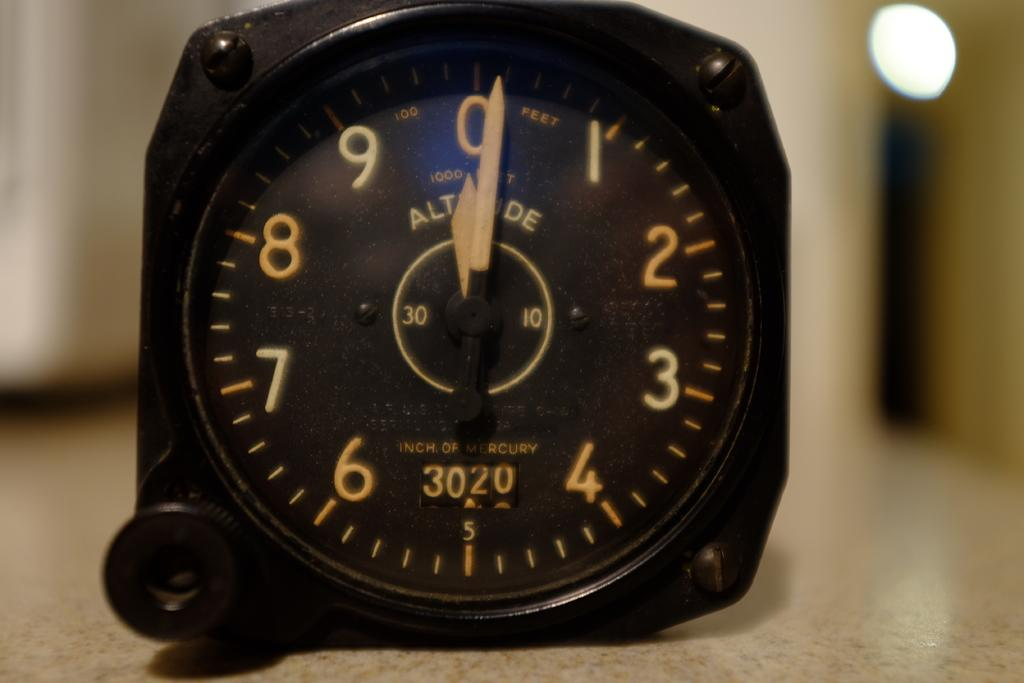<image>
Create a compact narrative representing the image presented. A clock that says "Inch of Mercury" on the bottom sits on a table 